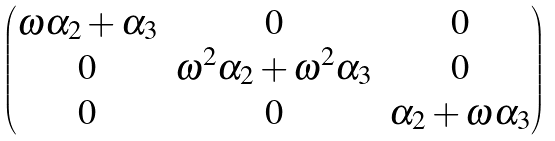<formula> <loc_0><loc_0><loc_500><loc_500>\begin{pmatrix} \omega \alpha _ { 2 } + \alpha _ { 3 } & 0 & 0 \\ 0 & \omega ^ { 2 } \alpha _ { 2 } + \omega ^ { 2 } \alpha _ { 3 } & 0 \\ 0 & 0 & \alpha _ { 2 } + \omega \alpha _ { 3 } \\ \end{pmatrix}</formula> 